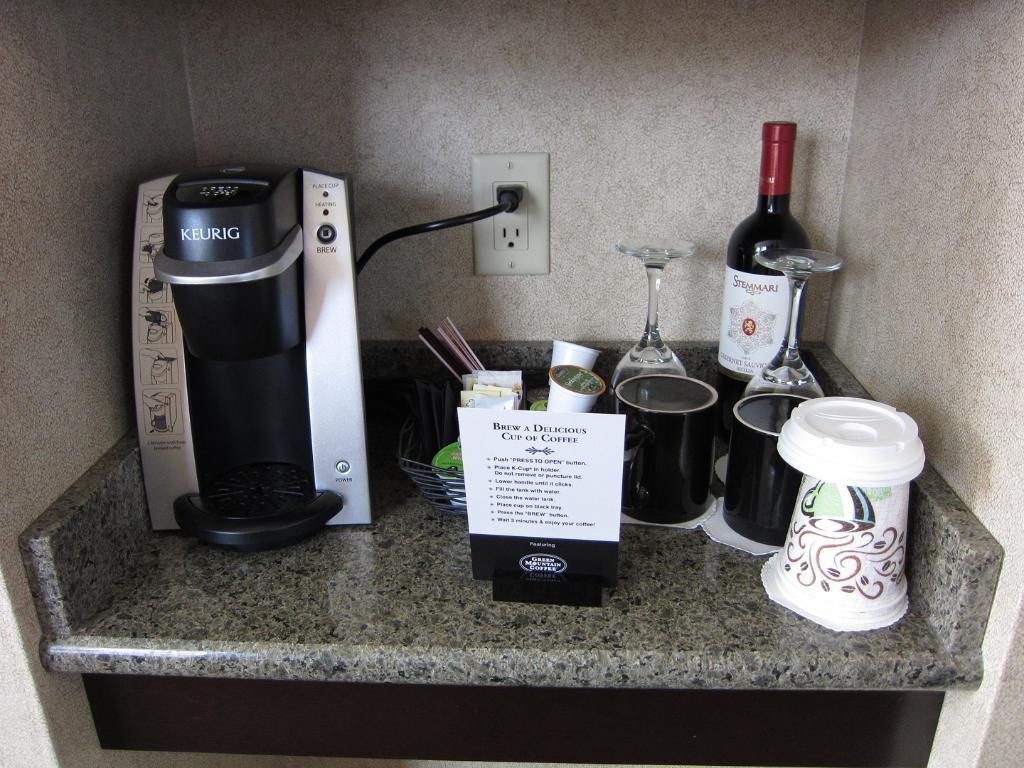<image>
Describe the image concisely. A sign with instructions on how to Brew a Delicious Cup of coffee. 